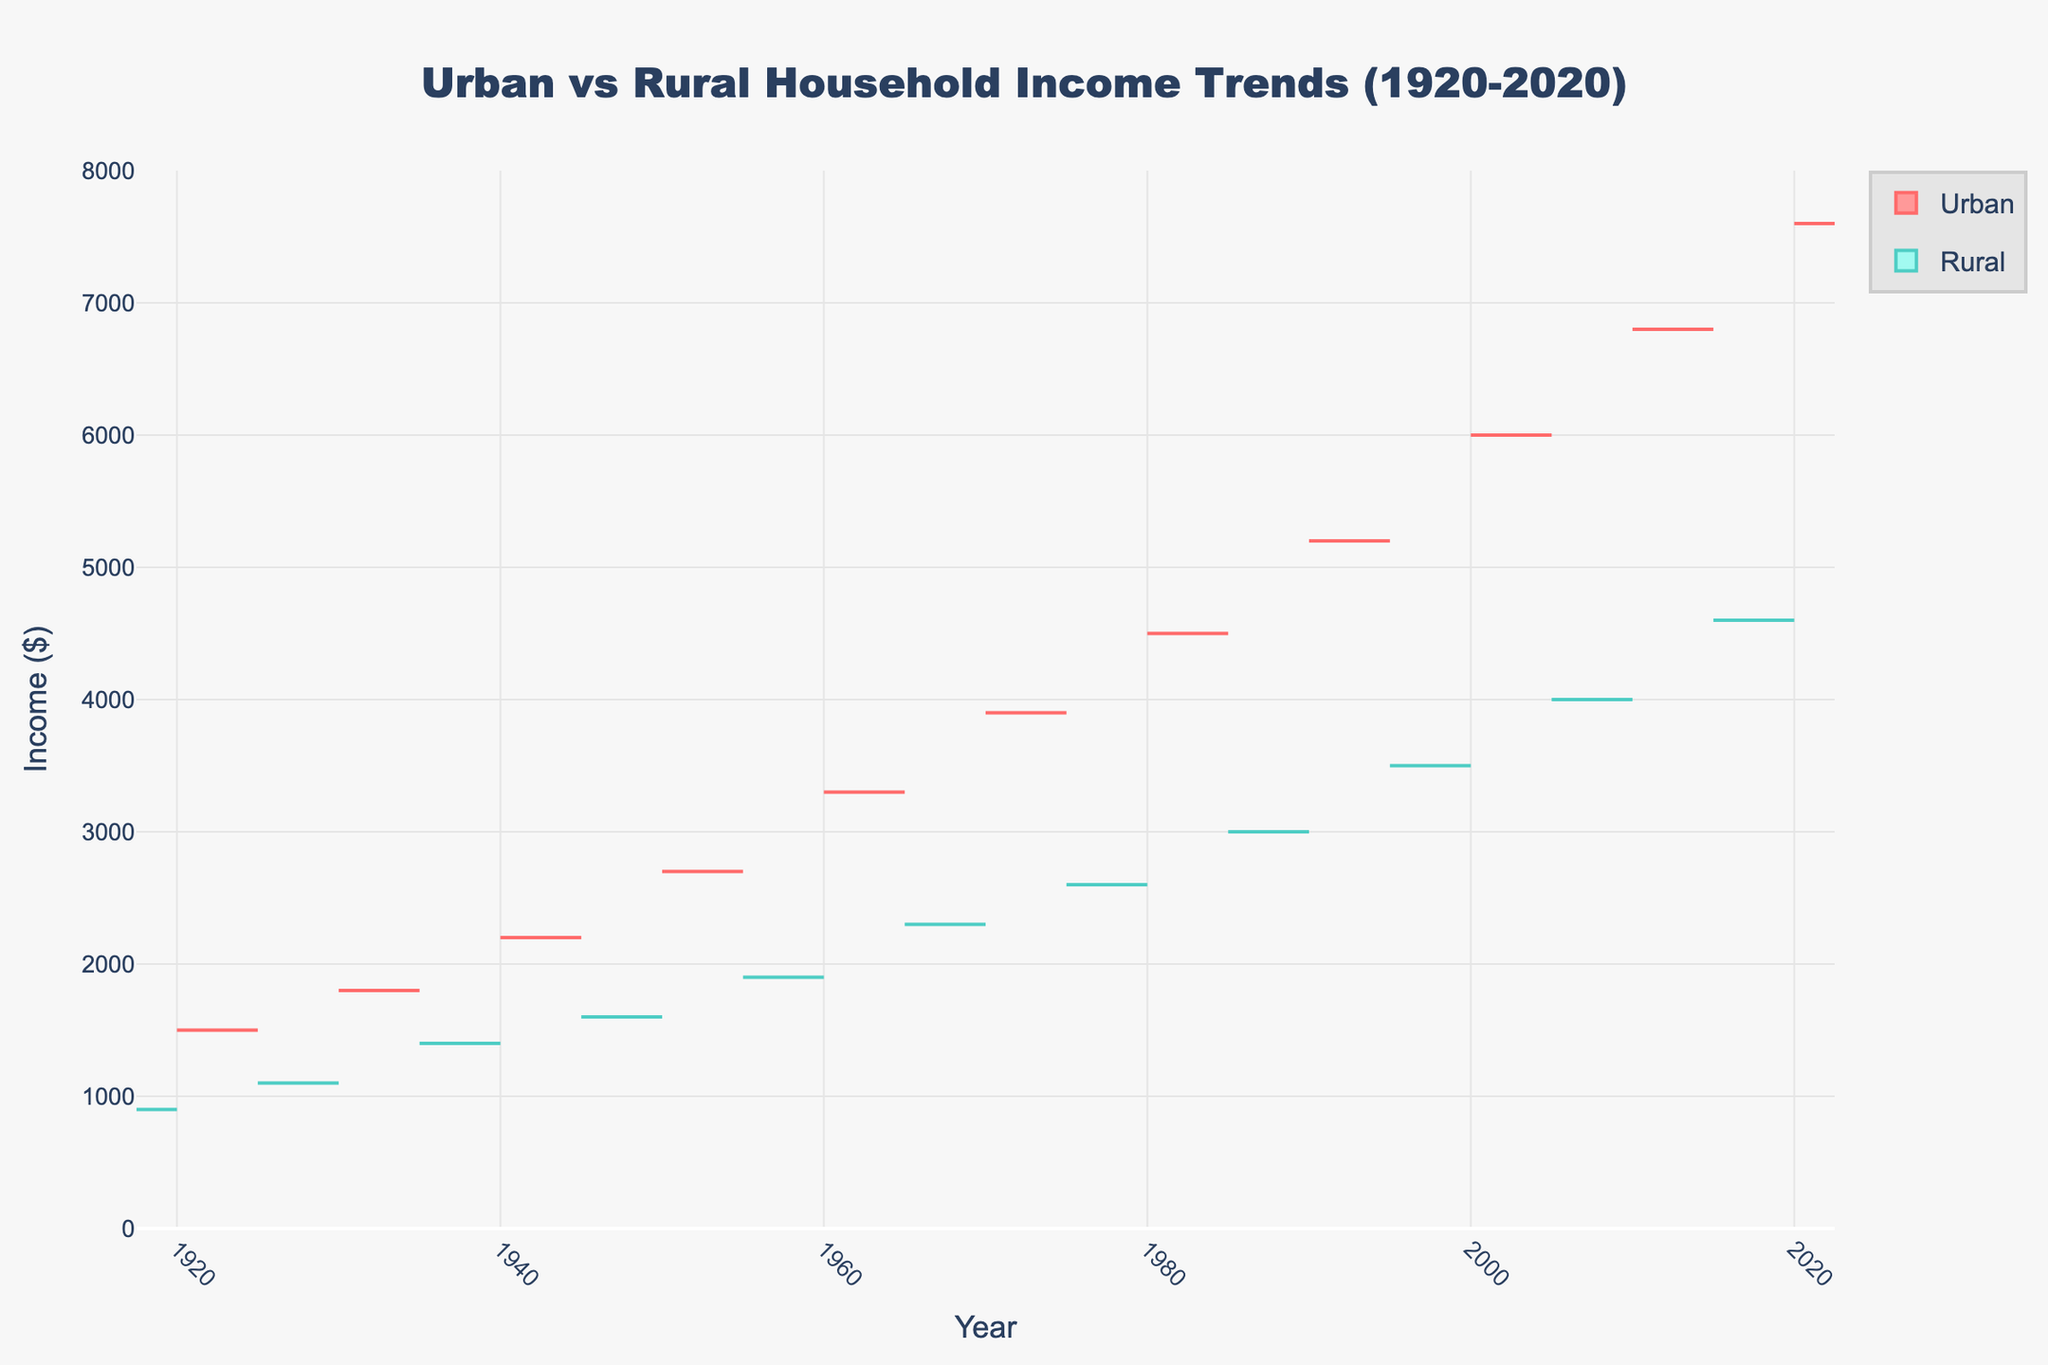What is the overall trend in urban household income from 1920 to 2020? The overall trend in urban household income from 1920 to 2020 shows a steady upward trajectory. Each decade, the household income in urban areas increases, reaching its peak in 2020. This is evident from the positive side of the split violin plot's gradual rise over the years.
Answer: Steady increase What is the title of the chart? The title of the chart is usually prominently displayed at the top of the figure. In this case, it reads, "Urban vs Rural Household Income Trends (1920-2020)".
Answer: Urban vs Rural Household Income Trends (1920-2020) How do the household incomes of rural areas compare to urban areas in 1950? By examining the points on the split violin chart at the year 1950, the urban household income is $2,700, while the rural household income is $1,600. Thus, urban household income is substantially higher than rural household income in 1950.
Answer: Urban income is higher What is the color used for rural data on the chart? The rural data is represented using a greenish-blue color for the violin plot on the negative side. Specifically, the lines are teal, and the fill is a lighter greenish-blue.
Answer: Greenish-blue Approximately how much higher is urban income compared to rural income in 2020? In 2020, the urban household income is $7,600, whereas the rural household income is $4,600. To find the difference: $7,600 - $4,600 = $3,000. Thus, urban income is approximately $3,000 higher than rural income in 2020.
Answer: $3,000 At what year did the rural household income first exceed $3,000? Observing the violin plot, the rural household income first exceeded $3,000 in 1990. This is the first year the value on the negative side surpasses this threshold.
Answer: 1990 How does the income distribution vary between urban and rural locations over time? The urban income consistently appears higher and shows a more pronounced increase over time, whereas the rural income, though it also increases, does so at a slower rate. The violin plots for urban incomes are wider, indicating a broader distribution in urban incomes as opposed to the relatively narrower distribution in rural incomes.
Answer: Urban has broader distribution and faster increase In which decade did urban household income surpass $5,000? Reviewing the violin plots, the urban household income surpasses $5,000 in the 1990s.
Answer: 1990s What trend can be observed about rural household income between 1920 and 1960? From the data visualized in the figure, rural household income shows a gradual increase from $900 in 1920 to $1,900 in 1960. This indicates a steady growth in rural household incomes over these four decades.
Answer: Steady growth 